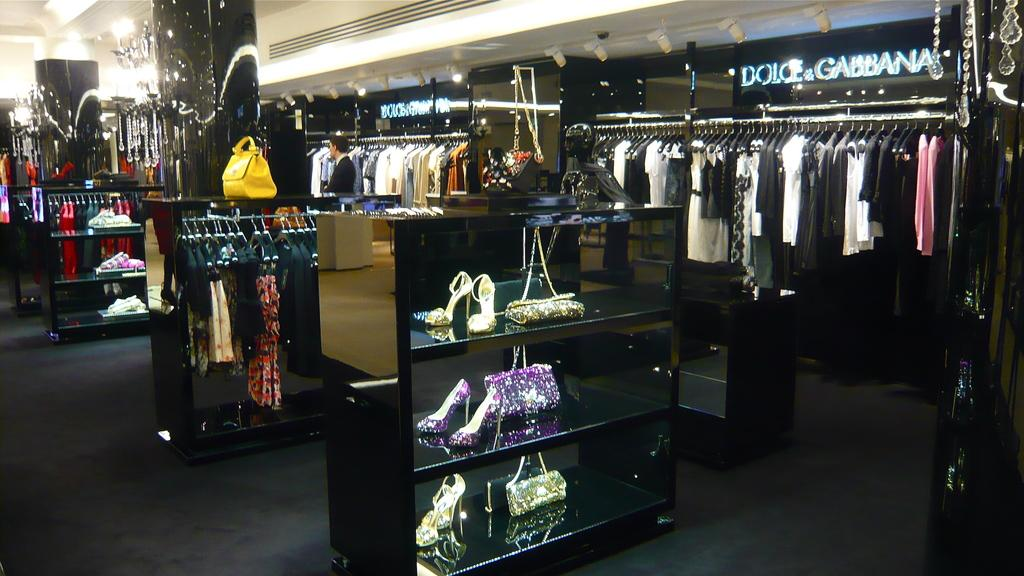<image>
Relay a brief, clear account of the picture shown. A section of a store contains clothes by Dolce & Gabbana. 